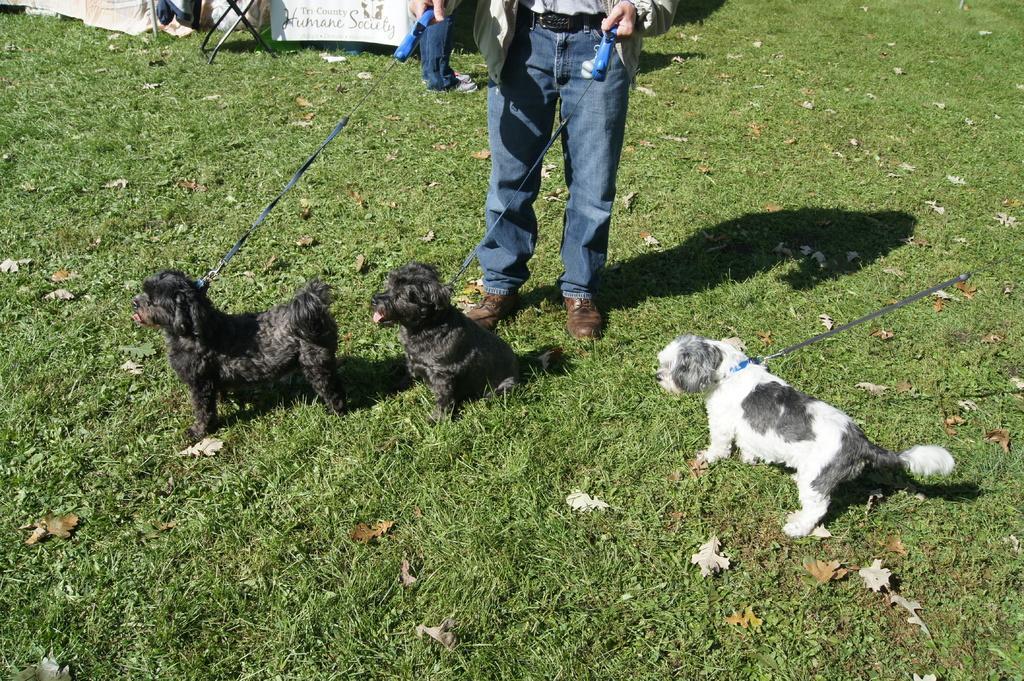How would you summarize this image in a sentence or two? In this image there are dogs in the center and there is a man holding ropes in his hand. In the background there is a banner with some text written on it, and there is a stand. On the ground there is grass and there are dry leaves on the grass. 